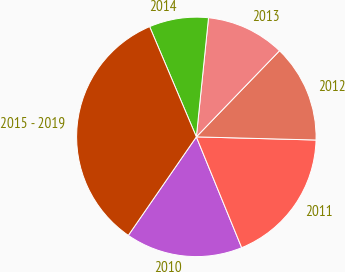Convert chart. <chart><loc_0><loc_0><loc_500><loc_500><pie_chart><fcel>2010<fcel>2011<fcel>2012<fcel>2013<fcel>2014<fcel>2015 - 2019<nl><fcel>15.8%<fcel>18.4%<fcel>13.2%<fcel>10.6%<fcel>8.0%<fcel>34.0%<nl></chart> 